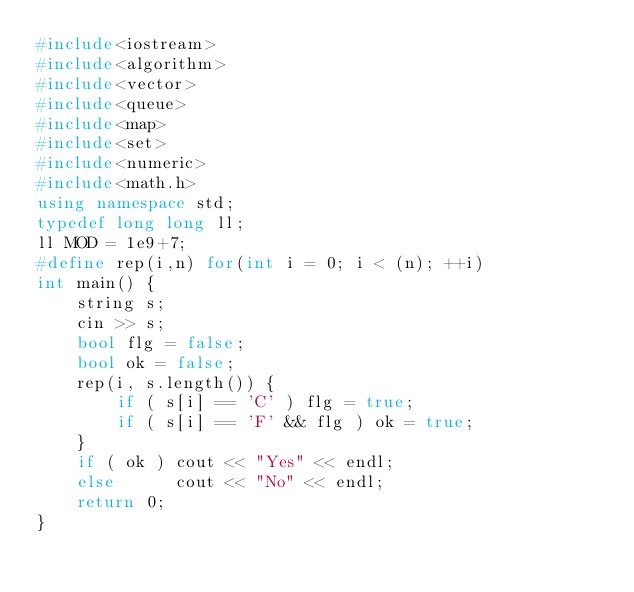Convert code to text. <code><loc_0><loc_0><loc_500><loc_500><_C++_>#include<iostream>
#include<algorithm>
#include<vector>
#include<queue>
#include<map>
#include<set>
#include<numeric>
#include<math.h>
using namespace std;
typedef long long ll;
ll MOD = 1e9+7;
#define rep(i,n) for(int i = 0; i < (n); ++i)
int main() {
    string s;
    cin >> s;
    bool flg = false;
    bool ok = false;
    rep(i, s.length()) {
        if ( s[i] == 'C' ) flg = true;
        if ( s[i] == 'F' && flg ) ok = true;
    }
    if ( ok ) cout << "Yes" << endl;
    else      cout << "No" << endl;
    return 0;
}
</code> 